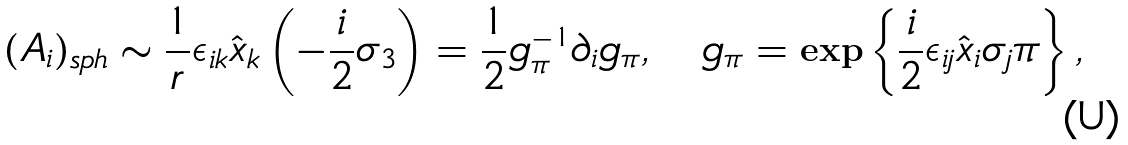<formula> <loc_0><loc_0><loc_500><loc_500>( A _ { i } ) _ { s p h } \sim \frac { 1 } { r } \epsilon _ { i k } \hat { x } _ { k } \left ( - \frac { i } { 2 } \sigma _ { 3 } \right ) = \frac { 1 } { 2 } g _ { \pi } ^ { - 1 } \partial _ { i } g _ { \pi } , \quad g _ { \pi } = \exp \left \{ \frac { i } { 2 } \epsilon _ { i j } \hat { x } _ { i } \sigma _ { j } \pi \right \} ,</formula> 